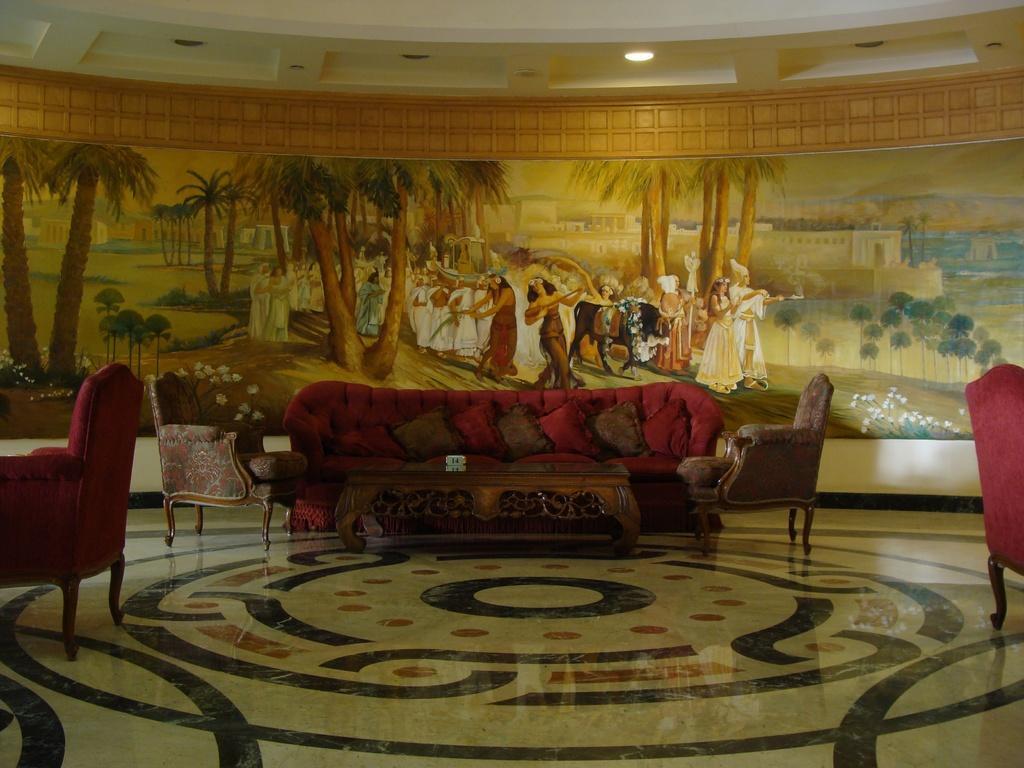In one or two sentences, can you explain what this image depicts? There is a sofa. This is floor. On the background there is a wall and this is painting. And there is a light. 